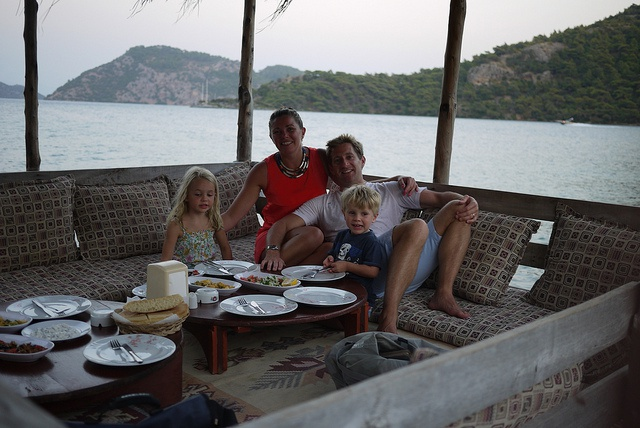Describe the objects in this image and their specific colors. I can see couch in lightgray, gray, and black tones, dining table in lightgray, black, gray, and darkgray tones, couch in lightgray, black, and gray tones, people in lightgray, black, gray, and maroon tones, and dining table in lightgray, black, darkgray, and gray tones in this image. 